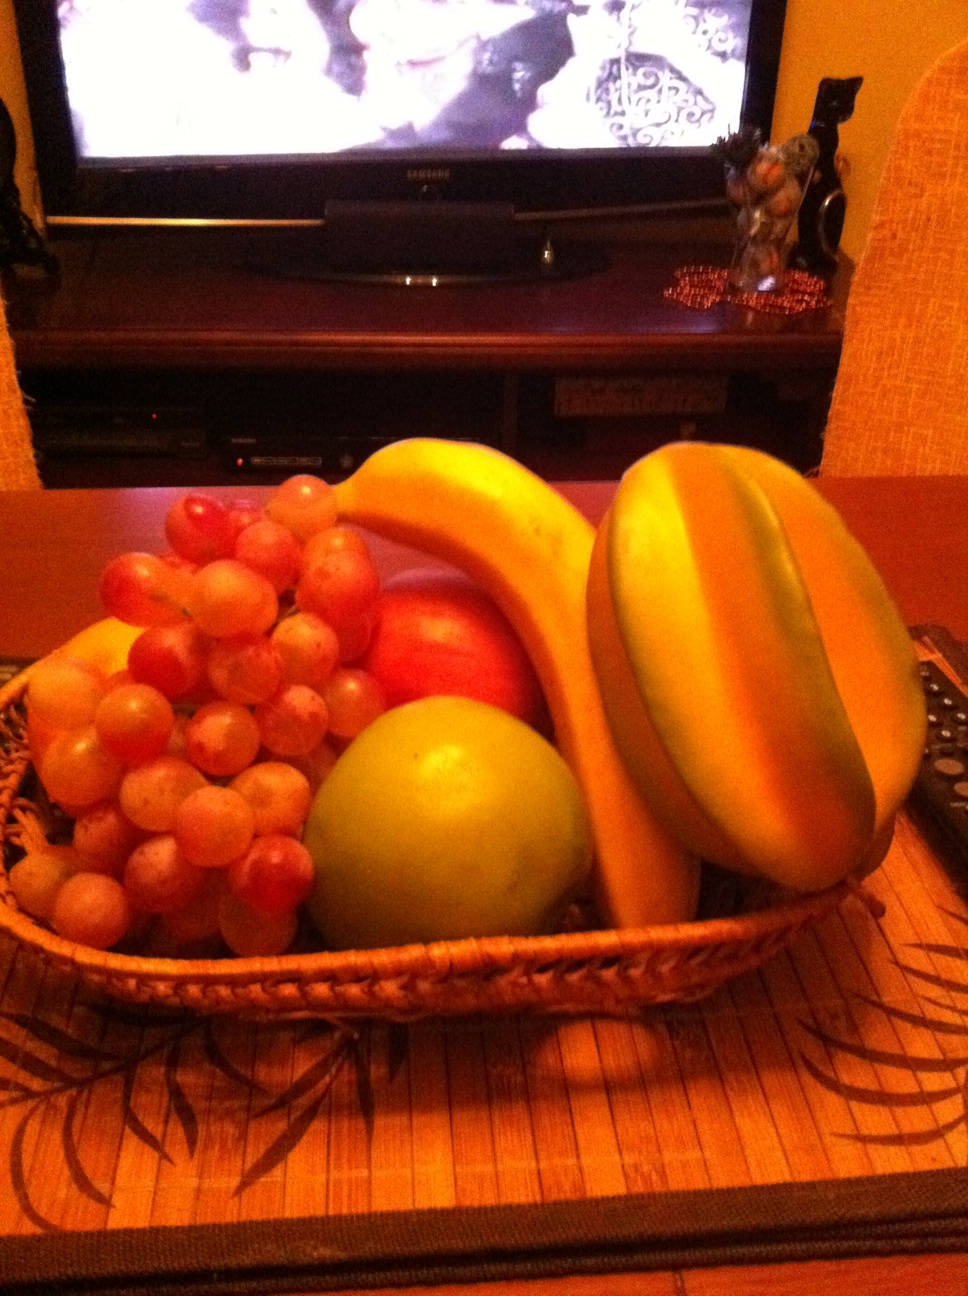Is this basket missing any fruits that would complement the selection? While the basket already has a nice variety, adding fruits like berries, oranges, or kiwis could enhance the range of flavors and nutritional profiles, offering more vitamin C and antioxidants.  How can I tell if the fruits in the basket are ripe and ready to eat? Ripeness can often be gauged by gently pressing the fruit to feel for a slight give, particularly in the case of the apple and papaya. The banana's skin should be a vibrant yellow with small brown spots, and the grapes should be firm to the touch with a plump appearance. 